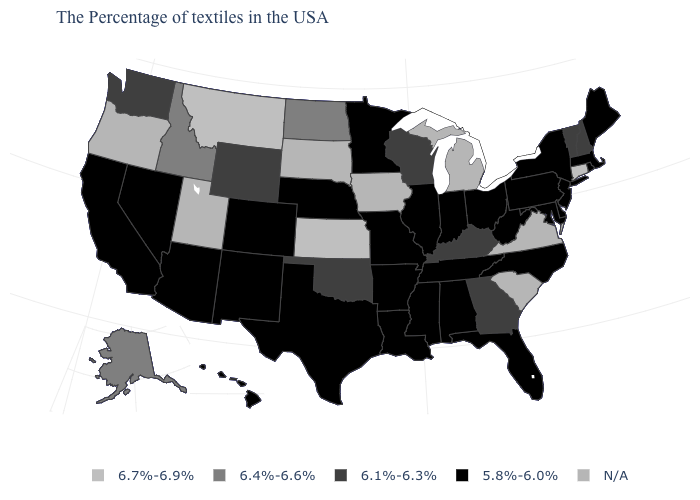Which states hav the highest value in the Northeast?
Short answer required. Connecticut. Which states have the lowest value in the USA?
Be succinct. Maine, Massachusetts, Rhode Island, New York, New Jersey, Delaware, Maryland, Pennsylvania, North Carolina, West Virginia, Ohio, Florida, Indiana, Alabama, Tennessee, Illinois, Mississippi, Louisiana, Missouri, Arkansas, Minnesota, Nebraska, Texas, Colorado, New Mexico, Arizona, Nevada, California, Hawaii. Name the states that have a value in the range 6.1%-6.3%?
Quick response, please. New Hampshire, Vermont, Georgia, Kentucky, Wisconsin, Oklahoma, Wyoming, Washington. What is the value of Louisiana?
Be succinct. 5.8%-6.0%. What is the lowest value in the USA?
Short answer required. 5.8%-6.0%. Is the legend a continuous bar?
Short answer required. No. Which states have the lowest value in the USA?
Keep it brief. Maine, Massachusetts, Rhode Island, New York, New Jersey, Delaware, Maryland, Pennsylvania, North Carolina, West Virginia, Ohio, Florida, Indiana, Alabama, Tennessee, Illinois, Mississippi, Louisiana, Missouri, Arkansas, Minnesota, Nebraska, Texas, Colorado, New Mexico, Arizona, Nevada, California, Hawaii. What is the value of New York?
Answer briefly. 5.8%-6.0%. Which states have the highest value in the USA?
Short answer required. Connecticut, Kansas, Montana. What is the lowest value in the MidWest?
Be succinct. 5.8%-6.0%. What is the lowest value in the USA?
Write a very short answer. 5.8%-6.0%. What is the value of Hawaii?
Concise answer only. 5.8%-6.0%. Does West Virginia have the lowest value in the USA?
Give a very brief answer. Yes. Name the states that have a value in the range 6.4%-6.6%?
Write a very short answer. North Dakota, Idaho, Alaska. What is the highest value in the South ?
Concise answer only. 6.1%-6.3%. 